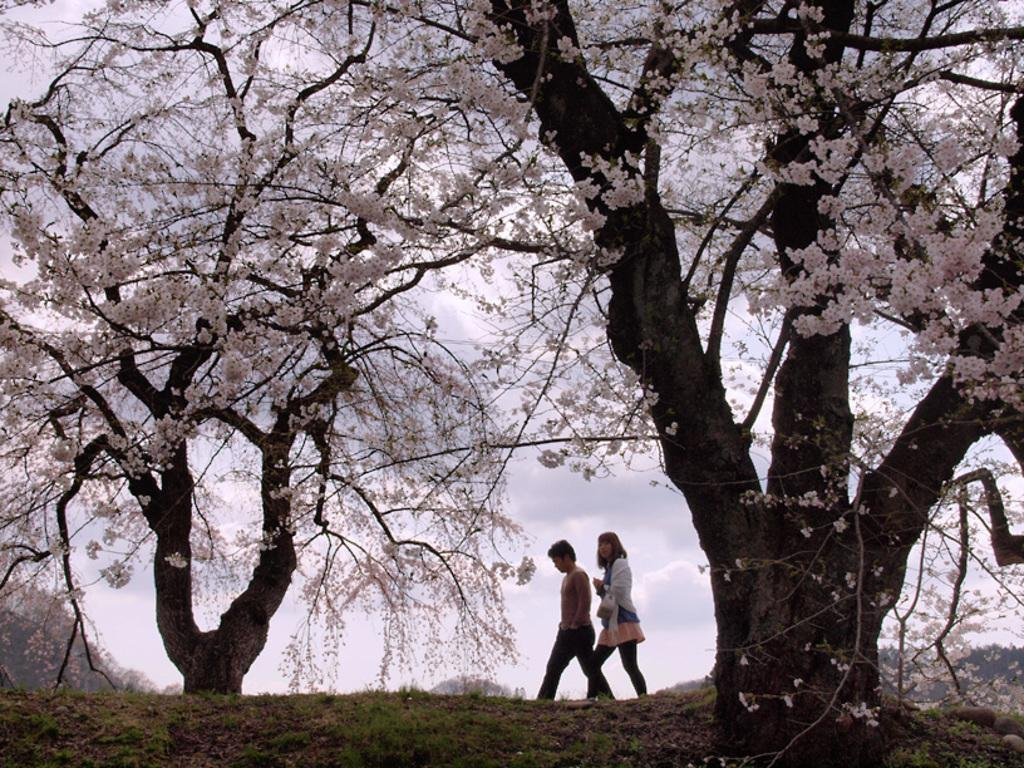What are the two persons in the image doing? The two persons in the image are walking. Can you describe the clothing of the person in front? The person in front is wearing a white shirt and black pants. What can be seen in the background of the image? There are dried trees and white-colored flowers in the background of the image. How would you describe the color of the sky in the image? The sky appears to be white in color. What type of cherries are being served at the feast in the image? There is no feast or cherries present in the image; it features two persons walking and a background with dried trees and white-colored flowers. How many waves can be seen crashing on the shore in the image? There is no shore or waves present in the image; it is focused on the two persons walking and the background elements. 